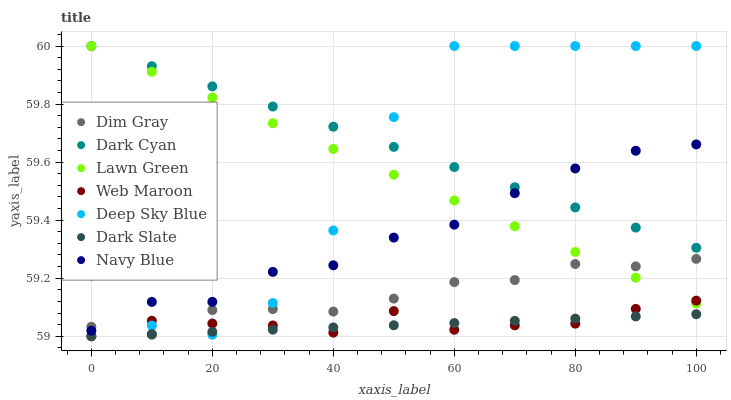Does Dark Slate have the minimum area under the curve?
Answer yes or no. Yes. Does Dark Cyan have the maximum area under the curve?
Answer yes or no. Yes. Does Dim Gray have the minimum area under the curve?
Answer yes or no. No. Does Dim Gray have the maximum area under the curve?
Answer yes or no. No. Is Dark Slate the smoothest?
Answer yes or no. Yes. Is Deep Sky Blue the roughest?
Answer yes or no. Yes. Is Dim Gray the smoothest?
Answer yes or no. No. Is Dim Gray the roughest?
Answer yes or no. No. Does Web Maroon have the lowest value?
Answer yes or no. Yes. Does Dim Gray have the lowest value?
Answer yes or no. No. Does Dark Cyan have the highest value?
Answer yes or no. Yes. Does Dim Gray have the highest value?
Answer yes or no. No. Is Dark Slate less than Navy Blue?
Answer yes or no. Yes. Is Dark Cyan greater than Dim Gray?
Answer yes or no. Yes. Does Deep Sky Blue intersect Web Maroon?
Answer yes or no. Yes. Is Deep Sky Blue less than Web Maroon?
Answer yes or no. No. Is Deep Sky Blue greater than Web Maroon?
Answer yes or no. No. Does Dark Slate intersect Navy Blue?
Answer yes or no. No. 